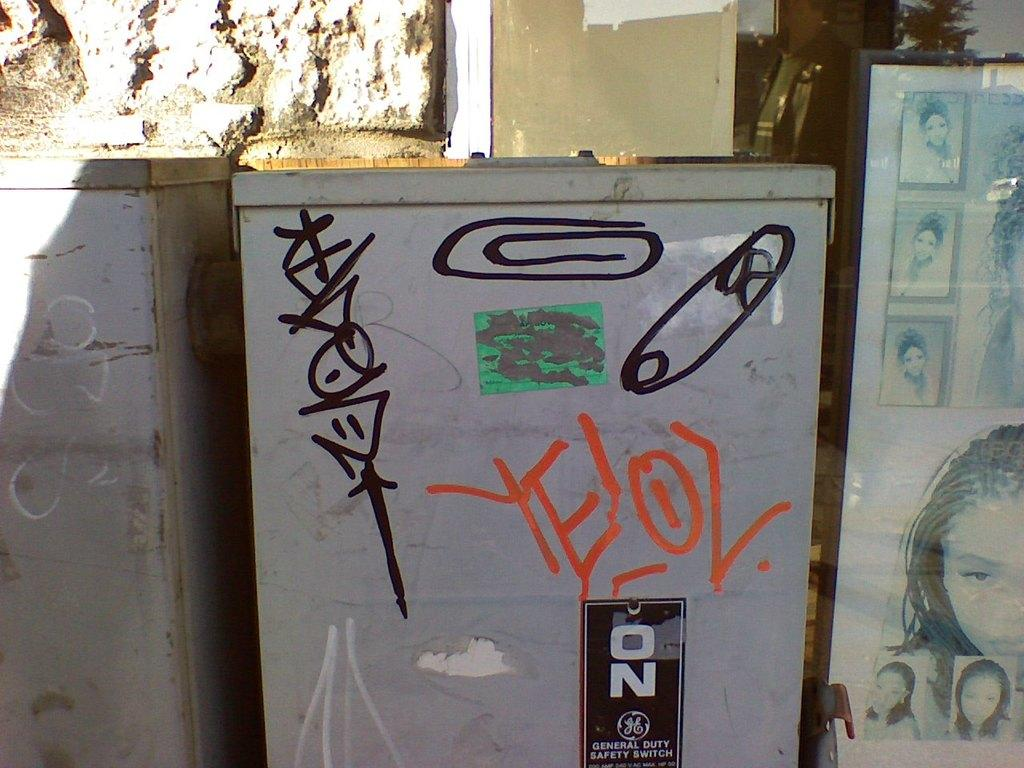What type of objects are present in the image? There are metal boxes in the image. What kind of barrier can be seen in the image? There is a glass wall in the image. Where are the photos of women located in the image? The photos of women are on the right side of the image. How do the chickens adjust to the metal boxes in the image? There are no chickens present in the image, so it is not possible to determine how they would adjust to the metal boxes. 